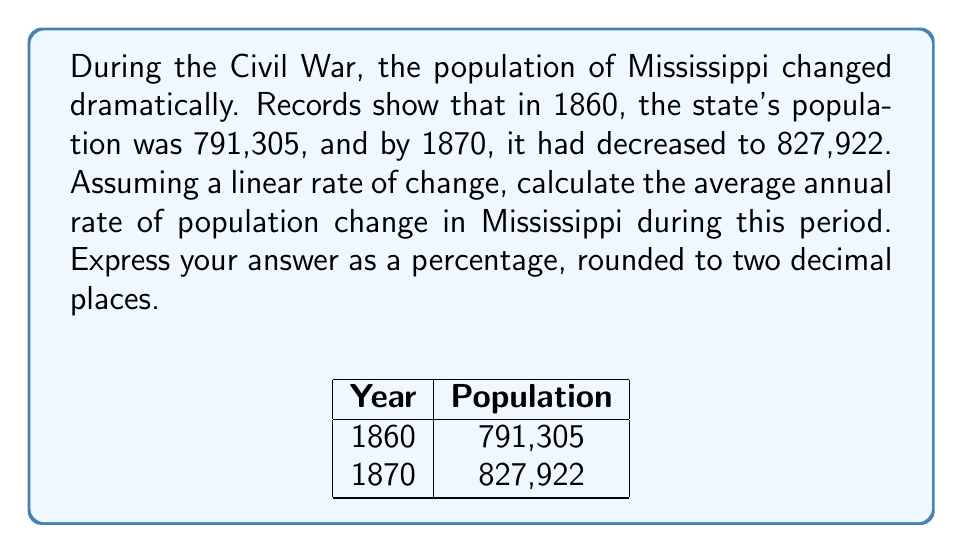Show me your answer to this math problem. Let's approach this step-by-step:

1) First, we need to calculate the total change in population:
   $$\Delta P = P_{1870} - P_{1860} = 827,922 - 791,305 = 36,617$$

2) The time period is 10 years (from 1860 to 1870).

3) To find the average annual rate of change, we divide the total change by the number of years:
   $$\text{Annual Change} = \frac{\Delta P}{\Delta t} = \frac{36,617}{10} = 3,661.7$$

4) To express this as a percentage of the initial population, we divide by the 1860 population and multiply by 100:
   $$\text{Percentage Rate} = \frac{\text{Annual Change}}{P_{1860}} \times 100$$
   
   $$= \frac{3,661.7}{791,305} \times 100 = 0.4627\%$$

5) Rounding to two decimal places:
   $$0.46\%$$

This positive rate indicates growth, which may seem counterintuitive given the context of the Civil War. However, it's important to note that population dynamics are complex, and factors such as migration, births, and deaths all play a role.
Answer: 0.46% 